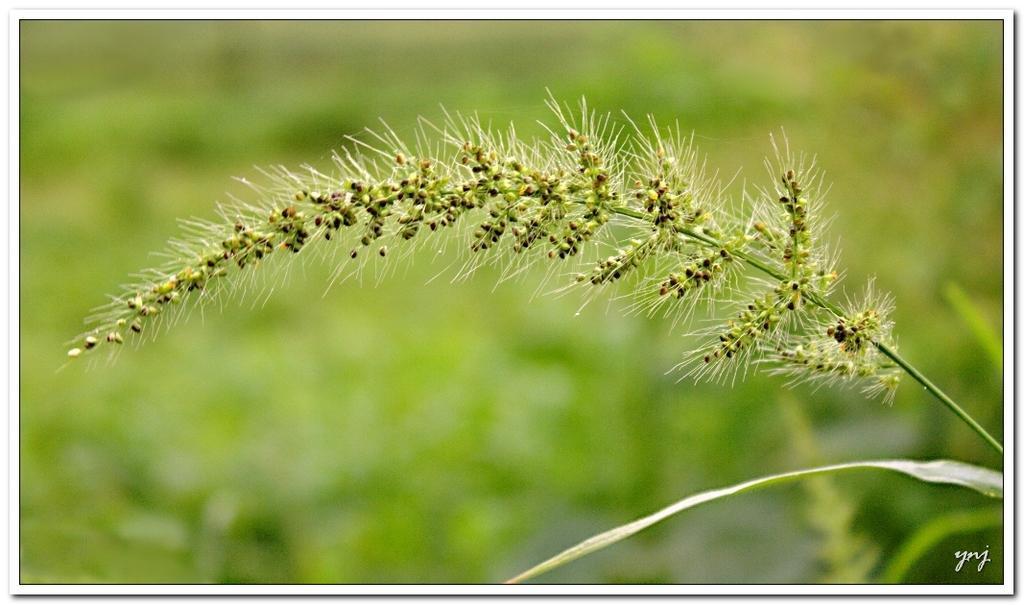Describe this image in one or two sentences. There is a stem with grains and white hair. There is a leaf. In the background it is green and blurred. In the right bottom corner there is a watermark. 